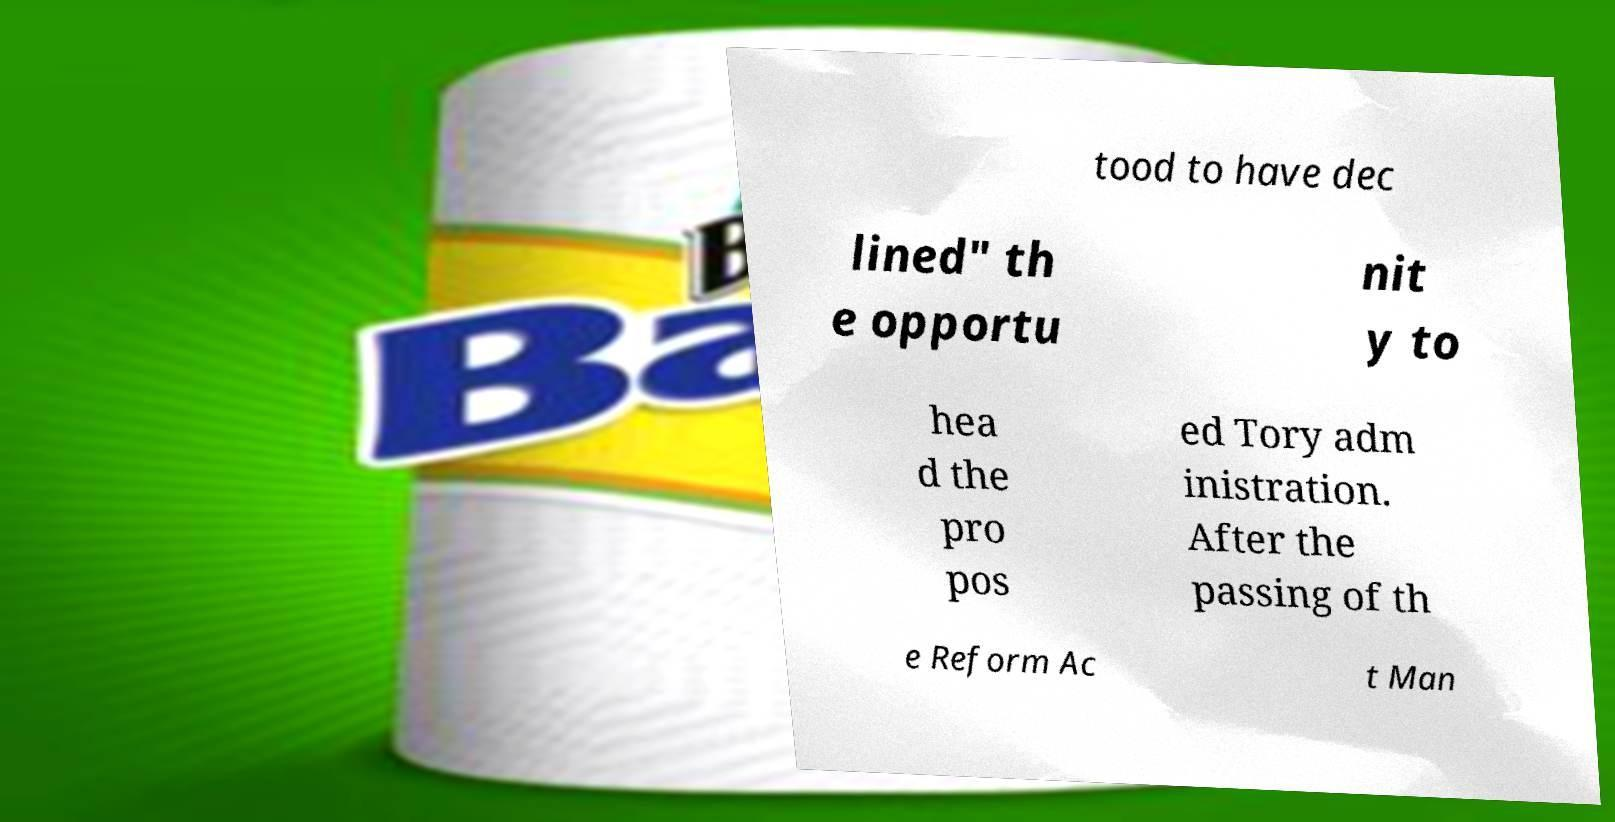Can you accurately transcribe the text from the provided image for me? tood to have dec lined" th e opportu nit y to hea d the pro pos ed Tory adm inistration. After the passing of th e Reform Ac t Man 